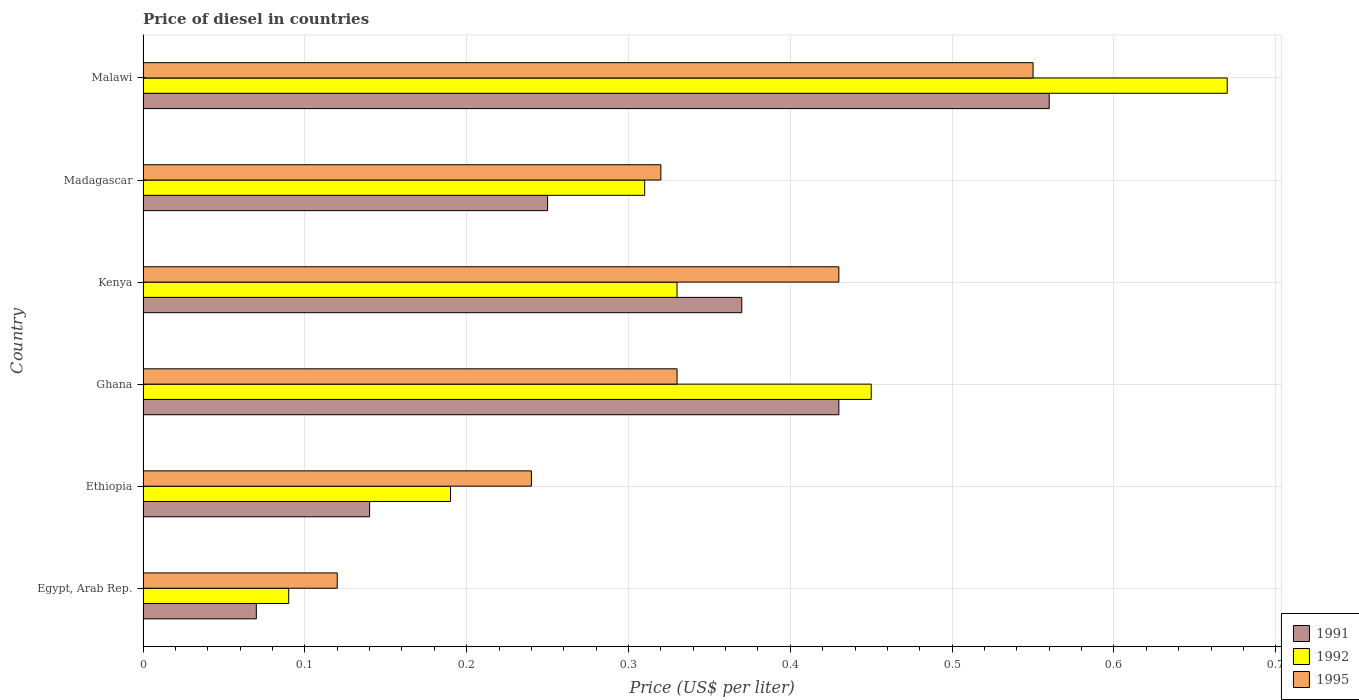How many groups of bars are there?
Your response must be concise. 6. Are the number of bars per tick equal to the number of legend labels?
Keep it short and to the point. Yes. Are the number of bars on each tick of the Y-axis equal?
Your answer should be very brief. Yes. How many bars are there on the 1st tick from the top?
Keep it short and to the point. 3. How many bars are there on the 5th tick from the bottom?
Keep it short and to the point. 3. What is the label of the 5th group of bars from the top?
Offer a very short reply. Ethiopia. In how many cases, is the number of bars for a given country not equal to the number of legend labels?
Ensure brevity in your answer.  0. What is the price of diesel in 1992 in Madagascar?
Your answer should be compact. 0.31. Across all countries, what is the maximum price of diesel in 1992?
Give a very brief answer. 0.67. Across all countries, what is the minimum price of diesel in 1995?
Your answer should be compact. 0.12. In which country was the price of diesel in 1992 maximum?
Offer a terse response. Malawi. In which country was the price of diesel in 1995 minimum?
Give a very brief answer. Egypt, Arab Rep. What is the total price of diesel in 1991 in the graph?
Ensure brevity in your answer.  1.82. What is the difference between the price of diesel in 1995 in Ghana and that in Kenya?
Provide a short and direct response. -0.1. What is the difference between the price of diesel in 1992 in Ethiopia and the price of diesel in 1991 in Egypt, Arab Rep.?
Your answer should be compact. 0.12. What is the average price of diesel in 1992 per country?
Your response must be concise. 0.34. What is the difference between the price of diesel in 1991 and price of diesel in 1995 in Madagascar?
Offer a very short reply. -0.07. What is the ratio of the price of diesel in 1995 in Ghana to that in Kenya?
Provide a short and direct response. 0.77. What is the difference between the highest and the second highest price of diesel in 1991?
Offer a very short reply. 0.13. What is the difference between the highest and the lowest price of diesel in 1992?
Make the answer very short. 0.58. Is the sum of the price of diesel in 1995 in Kenya and Madagascar greater than the maximum price of diesel in 1992 across all countries?
Provide a succinct answer. Yes. What does the 1st bar from the bottom in Ethiopia represents?
Give a very brief answer. 1991. How many bars are there?
Your response must be concise. 18. Are all the bars in the graph horizontal?
Keep it short and to the point. Yes. How many countries are there in the graph?
Provide a short and direct response. 6. Does the graph contain any zero values?
Your answer should be compact. No. Does the graph contain grids?
Your response must be concise. Yes. How are the legend labels stacked?
Provide a succinct answer. Vertical. What is the title of the graph?
Make the answer very short. Price of diesel in countries. Does "2000" appear as one of the legend labels in the graph?
Your answer should be very brief. No. What is the label or title of the X-axis?
Keep it short and to the point. Price (US$ per liter). What is the label or title of the Y-axis?
Offer a terse response. Country. What is the Price (US$ per liter) in 1991 in Egypt, Arab Rep.?
Your response must be concise. 0.07. What is the Price (US$ per liter) in 1992 in Egypt, Arab Rep.?
Provide a short and direct response. 0.09. What is the Price (US$ per liter) of 1995 in Egypt, Arab Rep.?
Your answer should be compact. 0.12. What is the Price (US$ per liter) in 1991 in Ethiopia?
Ensure brevity in your answer.  0.14. What is the Price (US$ per liter) in 1992 in Ethiopia?
Your answer should be very brief. 0.19. What is the Price (US$ per liter) of 1995 in Ethiopia?
Your response must be concise. 0.24. What is the Price (US$ per liter) in 1991 in Ghana?
Offer a terse response. 0.43. What is the Price (US$ per liter) of 1992 in Ghana?
Ensure brevity in your answer.  0.45. What is the Price (US$ per liter) of 1995 in Ghana?
Make the answer very short. 0.33. What is the Price (US$ per liter) of 1991 in Kenya?
Provide a short and direct response. 0.37. What is the Price (US$ per liter) in 1992 in Kenya?
Provide a succinct answer. 0.33. What is the Price (US$ per liter) of 1995 in Kenya?
Your response must be concise. 0.43. What is the Price (US$ per liter) in 1992 in Madagascar?
Your answer should be very brief. 0.31. What is the Price (US$ per liter) in 1995 in Madagascar?
Keep it short and to the point. 0.32. What is the Price (US$ per liter) in 1991 in Malawi?
Ensure brevity in your answer.  0.56. What is the Price (US$ per liter) of 1992 in Malawi?
Your answer should be compact. 0.67. What is the Price (US$ per liter) of 1995 in Malawi?
Keep it short and to the point. 0.55. Across all countries, what is the maximum Price (US$ per liter) in 1991?
Offer a terse response. 0.56. Across all countries, what is the maximum Price (US$ per liter) of 1992?
Offer a very short reply. 0.67. Across all countries, what is the maximum Price (US$ per liter) in 1995?
Your answer should be very brief. 0.55. Across all countries, what is the minimum Price (US$ per liter) in 1991?
Your answer should be compact. 0.07. Across all countries, what is the minimum Price (US$ per liter) of 1992?
Your response must be concise. 0.09. Across all countries, what is the minimum Price (US$ per liter) in 1995?
Offer a terse response. 0.12. What is the total Price (US$ per liter) of 1991 in the graph?
Offer a very short reply. 1.82. What is the total Price (US$ per liter) of 1992 in the graph?
Make the answer very short. 2.04. What is the total Price (US$ per liter) in 1995 in the graph?
Offer a very short reply. 1.99. What is the difference between the Price (US$ per liter) in 1991 in Egypt, Arab Rep. and that in Ethiopia?
Your response must be concise. -0.07. What is the difference between the Price (US$ per liter) of 1995 in Egypt, Arab Rep. and that in Ethiopia?
Ensure brevity in your answer.  -0.12. What is the difference between the Price (US$ per liter) in 1991 in Egypt, Arab Rep. and that in Ghana?
Your answer should be compact. -0.36. What is the difference between the Price (US$ per liter) of 1992 in Egypt, Arab Rep. and that in Ghana?
Offer a terse response. -0.36. What is the difference between the Price (US$ per liter) in 1995 in Egypt, Arab Rep. and that in Ghana?
Give a very brief answer. -0.21. What is the difference between the Price (US$ per liter) in 1992 in Egypt, Arab Rep. and that in Kenya?
Give a very brief answer. -0.24. What is the difference between the Price (US$ per liter) of 1995 in Egypt, Arab Rep. and that in Kenya?
Provide a succinct answer. -0.31. What is the difference between the Price (US$ per liter) of 1991 in Egypt, Arab Rep. and that in Madagascar?
Provide a succinct answer. -0.18. What is the difference between the Price (US$ per liter) in 1992 in Egypt, Arab Rep. and that in Madagascar?
Provide a succinct answer. -0.22. What is the difference between the Price (US$ per liter) in 1991 in Egypt, Arab Rep. and that in Malawi?
Your answer should be very brief. -0.49. What is the difference between the Price (US$ per liter) of 1992 in Egypt, Arab Rep. and that in Malawi?
Keep it short and to the point. -0.58. What is the difference between the Price (US$ per liter) of 1995 in Egypt, Arab Rep. and that in Malawi?
Give a very brief answer. -0.43. What is the difference between the Price (US$ per liter) in 1991 in Ethiopia and that in Ghana?
Ensure brevity in your answer.  -0.29. What is the difference between the Price (US$ per liter) in 1992 in Ethiopia and that in Ghana?
Offer a very short reply. -0.26. What is the difference between the Price (US$ per liter) in 1995 in Ethiopia and that in Ghana?
Make the answer very short. -0.09. What is the difference between the Price (US$ per liter) of 1991 in Ethiopia and that in Kenya?
Keep it short and to the point. -0.23. What is the difference between the Price (US$ per liter) in 1992 in Ethiopia and that in Kenya?
Offer a very short reply. -0.14. What is the difference between the Price (US$ per liter) of 1995 in Ethiopia and that in Kenya?
Offer a terse response. -0.19. What is the difference between the Price (US$ per liter) in 1991 in Ethiopia and that in Madagascar?
Offer a very short reply. -0.11. What is the difference between the Price (US$ per liter) of 1992 in Ethiopia and that in Madagascar?
Give a very brief answer. -0.12. What is the difference between the Price (US$ per liter) in 1995 in Ethiopia and that in Madagascar?
Provide a succinct answer. -0.08. What is the difference between the Price (US$ per liter) in 1991 in Ethiopia and that in Malawi?
Make the answer very short. -0.42. What is the difference between the Price (US$ per liter) of 1992 in Ethiopia and that in Malawi?
Your answer should be compact. -0.48. What is the difference between the Price (US$ per liter) of 1995 in Ethiopia and that in Malawi?
Provide a short and direct response. -0.31. What is the difference between the Price (US$ per liter) in 1991 in Ghana and that in Kenya?
Offer a very short reply. 0.06. What is the difference between the Price (US$ per liter) in 1992 in Ghana and that in Kenya?
Your answer should be very brief. 0.12. What is the difference between the Price (US$ per liter) of 1995 in Ghana and that in Kenya?
Your answer should be very brief. -0.1. What is the difference between the Price (US$ per liter) of 1991 in Ghana and that in Madagascar?
Your answer should be very brief. 0.18. What is the difference between the Price (US$ per liter) of 1992 in Ghana and that in Madagascar?
Your answer should be very brief. 0.14. What is the difference between the Price (US$ per liter) in 1995 in Ghana and that in Madagascar?
Provide a succinct answer. 0.01. What is the difference between the Price (US$ per liter) of 1991 in Ghana and that in Malawi?
Keep it short and to the point. -0.13. What is the difference between the Price (US$ per liter) of 1992 in Ghana and that in Malawi?
Provide a short and direct response. -0.22. What is the difference between the Price (US$ per liter) of 1995 in Ghana and that in Malawi?
Your response must be concise. -0.22. What is the difference between the Price (US$ per liter) of 1991 in Kenya and that in Madagascar?
Make the answer very short. 0.12. What is the difference between the Price (US$ per liter) in 1992 in Kenya and that in Madagascar?
Ensure brevity in your answer.  0.02. What is the difference between the Price (US$ per liter) in 1995 in Kenya and that in Madagascar?
Ensure brevity in your answer.  0.11. What is the difference between the Price (US$ per liter) in 1991 in Kenya and that in Malawi?
Your response must be concise. -0.19. What is the difference between the Price (US$ per liter) of 1992 in Kenya and that in Malawi?
Offer a terse response. -0.34. What is the difference between the Price (US$ per liter) of 1995 in Kenya and that in Malawi?
Your answer should be compact. -0.12. What is the difference between the Price (US$ per liter) in 1991 in Madagascar and that in Malawi?
Your answer should be very brief. -0.31. What is the difference between the Price (US$ per liter) of 1992 in Madagascar and that in Malawi?
Your response must be concise. -0.36. What is the difference between the Price (US$ per liter) in 1995 in Madagascar and that in Malawi?
Your response must be concise. -0.23. What is the difference between the Price (US$ per liter) in 1991 in Egypt, Arab Rep. and the Price (US$ per liter) in 1992 in Ethiopia?
Your response must be concise. -0.12. What is the difference between the Price (US$ per liter) in 1991 in Egypt, Arab Rep. and the Price (US$ per liter) in 1995 in Ethiopia?
Keep it short and to the point. -0.17. What is the difference between the Price (US$ per liter) of 1991 in Egypt, Arab Rep. and the Price (US$ per liter) of 1992 in Ghana?
Provide a short and direct response. -0.38. What is the difference between the Price (US$ per liter) of 1991 in Egypt, Arab Rep. and the Price (US$ per liter) of 1995 in Ghana?
Give a very brief answer. -0.26. What is the difference between the Price (US$ per liter) in 1992 in Egypt, Arab Rep. and the Price (US$ per liter) in 1995 in Ghana?
Your answer should be very brief. -0.24. What is the difference between the Price (US$ per liter) of 1991 in Egypt, Arab Rep. and the Price (US$ per liter) of 1992 in Kenya?
Your answer should be compact. -0.26. What is the difference between the Price (US$ per liter) in 1991 in Egypt, Arab Rep. and the Price (US$ per liter) in 1995 in Kenya?
Your answer should be very brief. -0.36. What is the difference between the Price (US$ per liter) in 1992 in Egypt, Arab Rep. and the Price (US$ per liter) in 1995 in Kenya?
Offer a very short reply. -0.34. What is the difference between the Price (US$ per liter) of 1991 in Egypt, Arab Rep. and the Price (US$ per liter) of 1992 in Madagascar?
Keep it short and to the point. -0.24. What is the difference between the Price (US$ per liter) of 1992 in Egypt, Arab Rep. and the Price (US$ per liter) of 1995 in Madagascar?
Provide a short and direct response. -0.23. What is the difference between the Price (US$ per liter) of 1991 in Egypt, Arab Rep. and the Price (US$ per liter) of 1995 in Malawi?
Your response must be concise. -0.48. What is the difference between the Price (US$ per liter) of 1992 in Egypt, Arab Rep. and the Price (US$ per liter) of 1995 in Malawi?
Your response must be concise. -0.46. What is the difference between the Price (US$ per liter) in 1991 in Ethiopia and the Price (US$ per liter) in 1992 in Ghana?
Keep it short and to the point. -0.31. What is the difference between the Price (US$ per liter) of 1991 in Ethiopia and the Price (US$ per liter) of 1995 in Ghana?
Offer a terse response. -0.19. What is the difference between the Price (US$ per liter) in 1992 in Ethiopia and the Price (US$ per liter) in 1995 in Ghana?
Offer a very short reply. -0.14. What is the difference between the Price (US$ per liter) in 1991 in Ethiopia and the Price (US$ per liter) in 1992 in Kenya?
Keep it short and to the point. -0.19. What is the difference between the Price (US$ per liter) of 1991 in Ethiopia and the Price (US$ per liter) of 1995 in Kenya?
Provide a succinct answer. -0.29. What is the difference between the Price (US$ per liter) in 1992 in Ethiopia and the Price (US$ per liter) in 1995 in Kenya?
Your answer should be compact. -0.24. What is the difference between the Price (US$ per liter) in 1991 in Ethiopia and the Price (US$ per liter) in 1992 in Madagascar?
Offer a terse response. -0.17. What is the difference between the Price (US$ per liter) of 1991 in Ethiopia and the Price (US$ per liter) of 1995 in Madagascar?
Keep it short and to the point. -0.18. What is the difference between the Price (US$ per liter) of 1992 in Ethiopia and the Price (US$ per liter) of 1995 in Madagascar?
Your answer should be very brief. -0.13. What is the difference between the Price (US$ per liter) in 1991 in Ethiopia and the Price (US$ per liter) in 1992 in Malawi?
Offer a very short reply. -0.53. What is the difference between the Price (US$ per liter) in 1991 in Ethiopia and the Price (US$ per liter) in 1995 in Malawi?
Offer a very short reply. -0.41. What is the difference between the Price (US$ per liter) in 1992 in Ethiopia and the Price (US$ per liter) in 1995 in Malawi?
Provide a succinct answer. -0.36. What is the difference between the Price (US$ per liter) of 1991 in Ghana and the Price (US$ per liter) of 1995 in Kenya?
Your answer should be compact. 0. What is the difference between the Price (US$ per liter) of 1991 in Ghana and the Price (US$ per liter) of 1992 in Madagascar?
Provide a succinct answer. 0.12. What is the difference between the Price (US$ per liter) in 1991 in Ghana and the Price (US$ per liter) in 1995 in Madagascar?
Offer a terse response. 0.11. What is the difference between the Price (US$ per liter) of 1992 in Ghana and the Price (US$ per liter) of 1995 in Madagascar?
Your response must be concise. 0.13. What is the difference between the Price (US$ per liter) of 1991 in Ghana and the Price (US$ per liter) of 1992 in Malawi?
Your answer should be very brief. -0.24. What is the difference between the Price (US$ per liter) in 1991 in Ghana and the Price (US$ per liter) in 1995 in Malawi?
Provide a succinct answer. -0.12. What is the difference between the Price (US$ per liter) of 1991 in Kenya and the Price (US$ per liter) of 1995 in Malawi?
Ensure brevity in your answer.  -0.18. What is the difference between the Price (US$ per liter) in 1992 in Kenya and the Price (US$ per liter) in 1995 in Malawi?
Keep it short and to the point. -0.22. What is the difference between the Price (US$ per liter) in 1991 in Madagascar and the Price (US$ per liter) in 1992 in Malawi?
Your response must be concise. -0.42. What is the difference between the Price (US$ per liter) in 1992 in Madagascar and the Price (US$ per liter) in 1995 in Malawi?
Offer a very short reply. -0.24. What is the average Price (US$ per liter) in 1991 per country?
Provide a succinct answer. 0.3. What is the average Price (US$ per liter) in 1992 per country?
Your answer should be very brief. 0.34. What is the average Price (US$ per liter) in 1995 per country?
Ensure brevity in your answer.  0.33. What is the difference between the Price (US$ per liter) in 1991 and Price (US$ per liter) in 1992 in Egypt, Arab Rep.?
Provide a short and direct response. -0.02. What is the difference between the Price (US$ per liter) in 1992 and Price (US$ per liter) in 1995 in Egypt, Arab Rep.?
Provide a succinct answer. -0.03. What is the difference between the Price (US$ per liter) of 1991 and Price (US$ per liter) of 1995 in Ethiopia?
Your answer should be very brief. -0.1. What is the difference between the Price (US$ per liter) in 1992 and Price (US$ per liter) in 1995 in Ethiopia?
Keep it short and to the point. -0.05. What is the difference between the Price (US$ per liter) in 1991 and Price (US$ per liter) in 1992 in Ghana?
Ensure brevity in your answer.  -0.02. What is the difference between the Price (US$ per liter) of 1991 and Price (US$ per liter) of 1995 in Ghana?
Ensure brevity in your answer.  0.1. What is the difference between the Price (US$ per liter) of 1992 and Price (US$ per liter) of 1995 in Ghana?
Ensure brevity in your answer.  0.12. What is the difference between the Price (US$ per liter) in 1991 and Price (US$ per liter) in 1995 in Kenya?
Your answer should be compact. -0.06. What is the difference between the Price (US$ per liter) in 1992 and Price (US$ per liter) in 1995 in Kenya?
Make the answer very short. -0.1. What is the difference between the Price (US$ per liter) of 1991 and Price (US$ per liter) of 1992 in Madagascar?
Your answer should be very brief. -0.06. What is the difference between the Price (US$ per liter) of 1991 and Price (US$ per liter) of 1995 in Madagascar?
Your answer should be very brief. -0.07. What is the difference between the Price (US$ per liter) in 1992 and Price (US$ per liter) in 1995 in Madagascar?
Your answer should be compact. -0.01. What is the difference between the Price (US$ per liter) of 1991 and Price (US$ per liter) of 1992 in Malawi?
Your answer should be compact. -0.11. What is the difference between the Price (US$ per liter) of 1992 and Price (US$ per liter) of 1995 in Malawi?
Your answer should be very brief. 0.12. What is the ratio of the Price (US$ per liter) in 1991 in Egypt, Arab Rep. to that in Ethiopia?
Your answer should be compact. 0.5. What is the ratio of the Price (US$ per liter) of 1992 in Egypt, Arab Rep. to that in Ethiopia?
Provide a succinct answer. 0.47. What is the ratio of the Price (US$ per liter) of 1991 in Egypt, Arab Rep. to that in Ghana?
Make the answer very short. 0.16. What is the ratio of the Price (US$ per liter) in 1995 in Egypt, Arab Rep. to that in Ghana?
Offer a very short reply. 0.36. What is the ratio of the Price (US$ per liter) in 1991 in Egypt, Arab Rep. to that in Kenya?
Offer a very short reply. 0.19. What is the ratio of the Price (US$ per liter) in 1992 in Egypt, Arab Rep. to that in Kenya?
Offer a terse response. 0.27. What is the ratio of the Price (US$ per liter) in 1995 in Egypt, Arab Rep. to that in Kenya?
Your answer should be compact. 0.28. What is the ratio of the Price (US$ per liter) in 1991 in Egypt, Arab Rep. to that in Madagascar?
Ensure brevity in your answer.  0.28. What is the ratio of the Price (US$ per liter) in 1992 in Egypt, Arab Rep. to that in Madagascar?
Your response must be concise. 0.29. What is the ratio of the Price (US$ per liter) of 1995 in Egypt, Arab Rep. to that in Madagascar?
Give a very brief answer. 0.38. What is the ratio of the Price (US$ per liter) in 1991 in Egypt, Arab Rep. to that in Malawi?
Make the answer very short. 0.12. What is the ratio of the Price (US$ per liter) of 1992 in Egypt, Arab Rep. to that in Malawi?
Keep it short and to the point. 0.13. What is the ratio of the Price (US$ per liter) of 1995 in Egypt, Arab Rep. to that in Malawi?
Provide a short and direct response. 0.22. What is the ratio of the Price (US$ per liter) in 1991 in Ethiopia to that in Ghana?
Provide a short and direct response. 0.33. What is the ratio of the Price (US$ per liter) of 1992 in Ethiopia to that in Ghana?
Offer a very short reply. 0.42. What is the ratio of the Price (US$ per liter) of 1995 in Ethiopia to that in Ghana?
Your answer should be compact. 0.73. What is the ratio of the Price (US$ per liter) of 1991 in Ethiopia to that in Kenya?
Your answer should be compact. 0.38. What is the ratio of the Price (US$ per liter) in 1992 in Ethiopia to that in Kenya?
Give a very brief answer. 0.58. What is the ratio of the Price (US$ per liter) of 1995 in Ethiopia to that in Kenya?
Offer a very short reply. 0.56. What is the ratio of the Price (US$ per liter) in 1991 in Ethiopia to that in Madagascar?
Offer a terse response. 0.56. What is the ratio of the Price (US$ per liter) of 1992 in Ethiopia to that in Madagascar?
Provide a short and direct response. 0.61. What is the ratio of the Price (US$ per liter) in 1992 in Ethiopia to that in Malawi?
Ensure brevity in your answer.  0.28. What is the ratio of the Price (US$ per liter) of 1995 in Ethiopia to that in Malawi?
Offer a very short reply. 0.44. What is the ratio of the Price (US$ per liter) in 1991 in Ghana to that in Kenya?
Your response must be concise. 1.16. What is the ratio of the Price (US$ per liter) of 1992 in Ghana to that in Kenya?
Your answer should be compact. 1.36. What is the ratio of the Price (US$ per liter) of 1995 in Ghana to that in Kenya?
Offer a very short reply. 0.77. What is the ratio of the Price (US$ per liter) of 1991 in Ghana to that in Madagascar?
Your answer should be very brief. 1.72. What is the ratio of the Price (US$ per liter) in 1992 in Ghana to that in Madagascar?
Provide a succinct answer. 1.45. What is the ratio of the Price (US$ per liter) in 1995 in Ghana to that in Madagascar?
Provide a succinct answer. 1.03. What is the ratio of the Price (US$ per liter) in 1991 in Ghana to that in Malawi?
Provide a succinct answer. 0.77. What is the ratio of the Price (US$ per liter) of 1992 in Ghana to that in Malawi?
Your answer should be very brief. 0.67. What is the ratio of the Price (US$ per liter) in 1991 in Kenya to that in Madagascar?
Make the answer very short. 1.48. What is the ratio of the Price (US$ per liter) in 1992 in Kenya to that in Madagascar?
Offer a terse response. 1.06. What is the ratio of the Price (US$ per liter) of 1995 in Kenya to that in Madagascar?
Give a very brief answer. 1.34. What is the ratio of the Price (US$ per liter) of 1991 in Kenya to that in Malawi?
Your answer should be very brief. 0.66. What is the ratio of the Price (US$ per liter) of 1992 in Kenya to that in Malawi?
Ensure brevity in your answer.  0.49. What is the ratio of the Price (US$ per liter) of 1995 in Kenya to that in Malawi?
Offer a terse response. 0.78. What is the ratio of the Price (US$ per liter) of 1991 in Madagascar to that in Malawi?
Offer a very short reply. 0.45. What is the ratio of the Price (US$ per liter) in 1992 in Madagascar to that in Malawi?
Make the answer very short. 0.46. What is the ratio of the Price (US$ per liter) in 1995 in Madagascar to that in Malawi?
Your response must be concise. 0.58. What is the difference between the highest and the second highest Price (US$ per liter) in 1991?
Keep it short and to the point. 0.13. What is the difference between the highest and the second highest Price (US$ per liter) in 1992?
Make the answer very short. 0.22. What is the difference between the highest and the second highest Price (US$ per liter) in 1995?
Give a very brief answer. 0.12. What is the difference between the highest and the lowest Price (US$ per liter) in 1991?
Give a very brief answer. 0.49. What is the difference between the highest and the lowest Price (US$ per liter) of 1992?
Provide a short and direct response. 0.58. What is the difference between the highest and the lowest Price (US$ per liter) of 1995?
Keep it short and to the point. 0.43. 